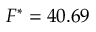<formula> <loc_0><loc_0><loc_500><loc_500>{ F } ^ { * } = 4 0 . 6 9</formula> 